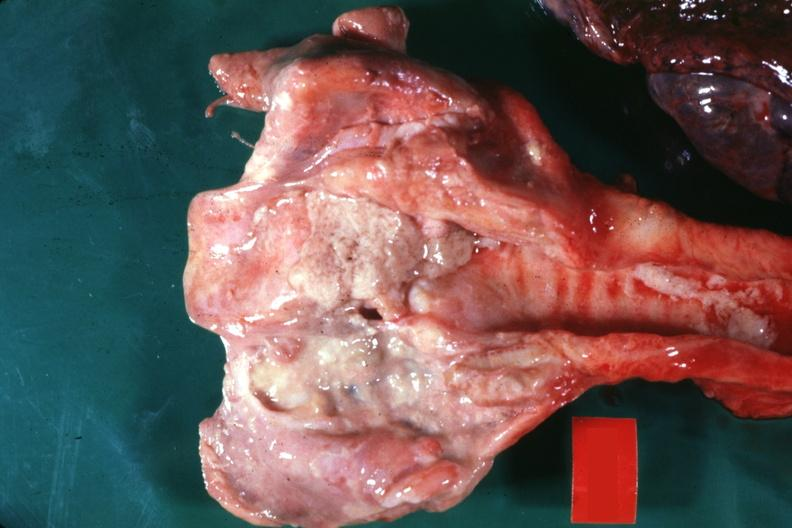s larynx present?
Answer the question using a single word or phrase. Yes 